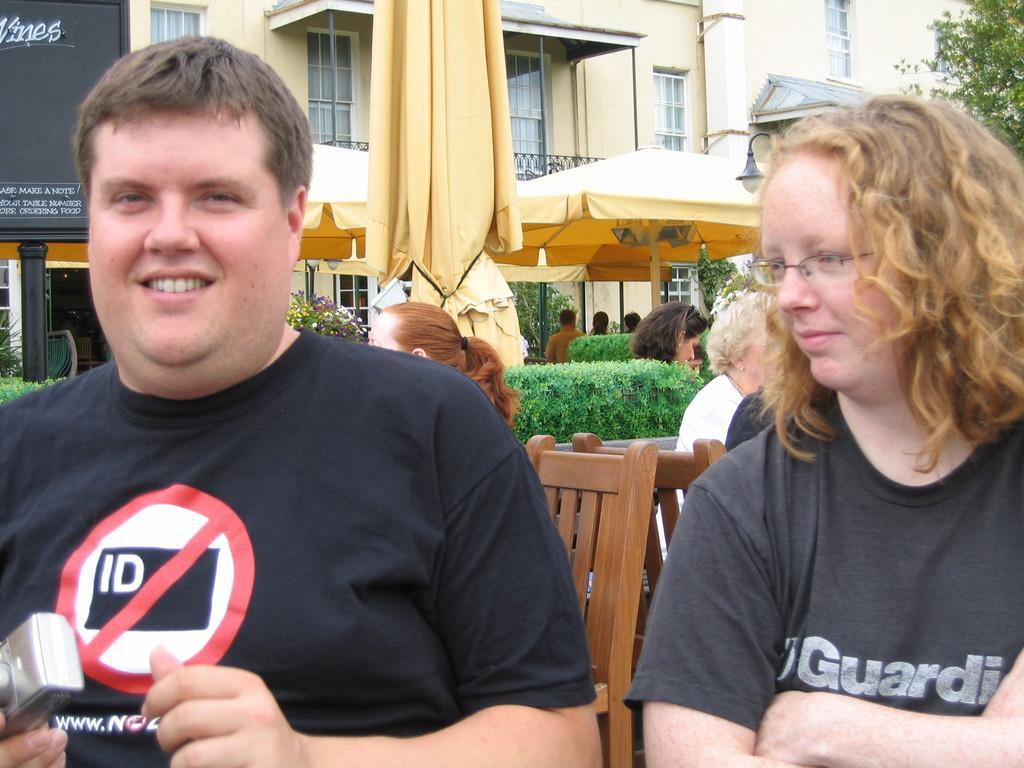<image>
Describe the image concisely. A young man wears a t-shirt with a no ID symbol on it. 